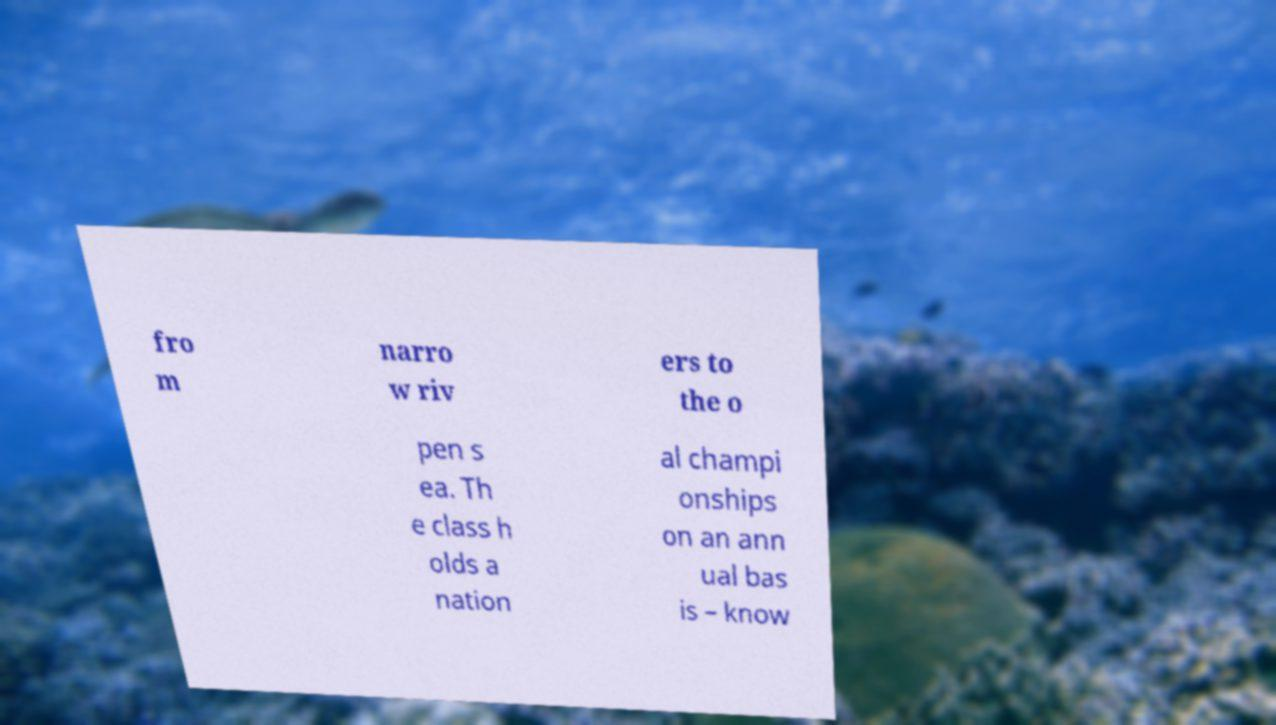There's text embedded in this image that I need extracted. Can you transcribe it verbatim? fro m narro w riv ers to the o pen s ea. Th e class h olds a nation al champi onships on an ann ual bas is – know 